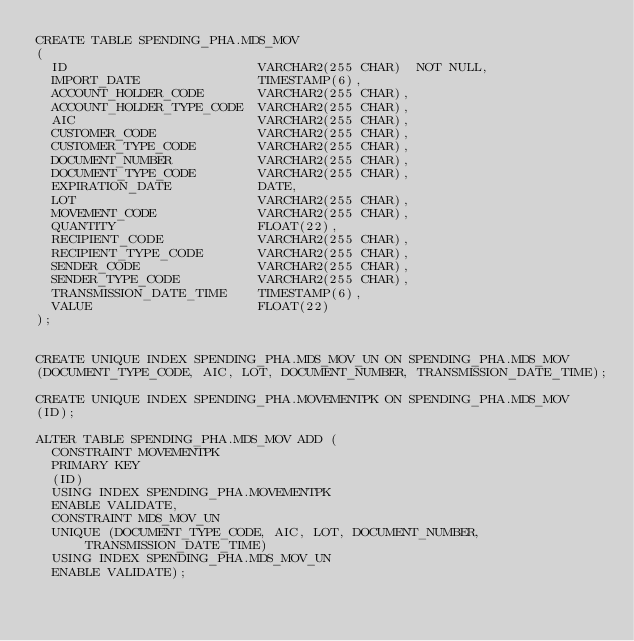<code> <loc_0><loc_0><loc_500><loc_500><_SQL_>CREATE TABLE SPENDING_PHA.MDS_MOV
(
  ID                        VARCHAR2(255 CHAR)  NOT NULL,
  IMPORT_DATE               TIMESTAMP(6),
  ACCOUNT_HOLDER_CODE       VARCHAR2(255 CHAR),
  ACCOUNT_HOLDER_TYPE_CODE  VARCHAR2(255 CHAR),
  AIC                       VARCHAR2(255 CHAR),
  CUSTOMER_CODE             VARCHAR2(255 CHAR),
  CUSTOMER_TYPE_CODE        VARCHAR2(255 CHAR),
  DOCUMENT_NUMBER           VARCHAR2(255 CHAR),
  DOCUMENT_TYPE_CODE        VARCHAR2(255 CHAR),
  EXPIRATION_DATE           DATE,
  LOT                       VARCHAR2(255 CHAR),
  MOVEMENT_CODE             VARCHAR2(255 CHAR),
  QUANTITY                  FLOAT(22),
  RECIPIENT_CODE            VARCHAR2(255 CHAR),
  RECIPIENT_TYPE_CODE       VARCHAR2(255 CHAR),
  SENDER_CODE               VARCHAR2(255 CHAR),
  SENDER_TYPE_CODE          VARCHAR2(255 CHAR),
  TRANSMISSION_DATE_TIME    TIMESTAMP(6),
  VALUE                     FLOAT(22)
);


CREATE UNIQUE INDEX SPENDING_PHA.MDS_MOV_UN ON SPENDING_PHA.MDS_MOV
(DOCUMENT_TYPE_CODE, AIC, LOT, DOCUMENT_NUMBER, TRANSMISSION_DATE_TIME);

CREATE UNIQUE INDEX SPENDING_PHA.MOVEMENTPK ON SPENDING_PHA.MDS_MOV
(ID);

ALTER TABLE SPENDING_PHA.MDS_MOV ADD (
  CONSTRAINT MOVEMENTPK
  PRIMARY KEY
  (ID)
  USING INDEX SPENDING_PHA.MOVEMENTPK
  ENABLE VALIDATE,
  CONSTRAINT MDS_MOV_UN
  UNIQUE (DOCUMENT_TYPE_CODE, AIC, LOT, DOCUMENT_NUMBER, TRANSMISSION_DATE_TIME)
  USING INDEX SPENDING_PHA.MDS_MOV_UN
  ENABLE VALIDATE);</code> 